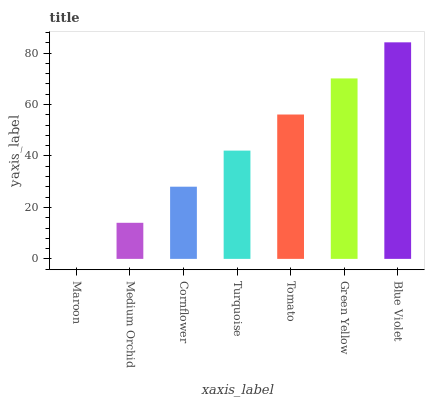Is Maroon the minimum?
Answer yes or no. Yes. Is Blue Violet the maximum?
Answer yes or no. Yes. Is Medium Orchid the minimum?
Answer yes or no. No. Is Medium Orchid the maximum?
Answer yes or no. No. Is Medium Orchid greater than Maroon?
Answer yes or no. Yes. Is Maroon less than Medium Orchid?
Answer yes or no. Yes. Is Maroon greater than Medium Orchid?
Answer yes or no. No. Is Medium Orchid less than Maroon?
Answer yes or no. No. Is Turquoise the high median?
Answer yes or no. Yes. Is Turquoise the low median?
Answer yes or no. Yes. Is Maroon the high median?
Answer yes or no. No. Is Medium Orchid the low median?
Answer yes or no. No. 